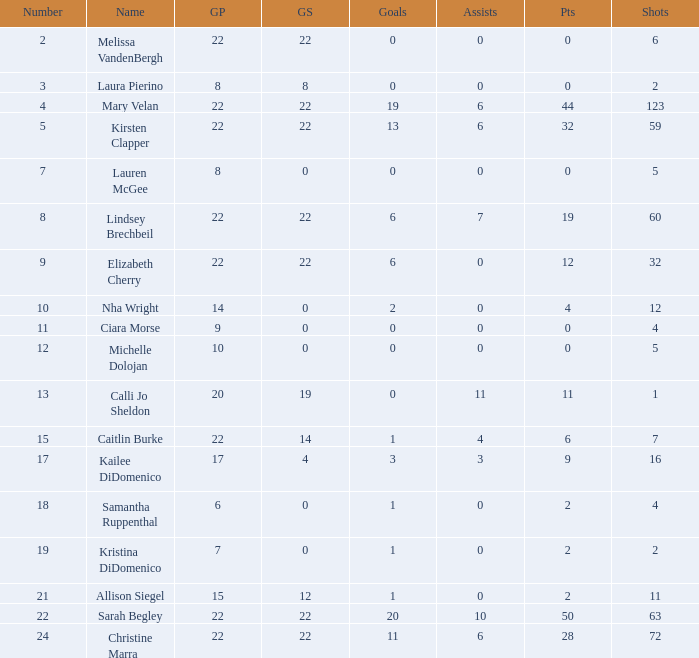How many games played catagories are there for Lauren McGee?  1.0. 